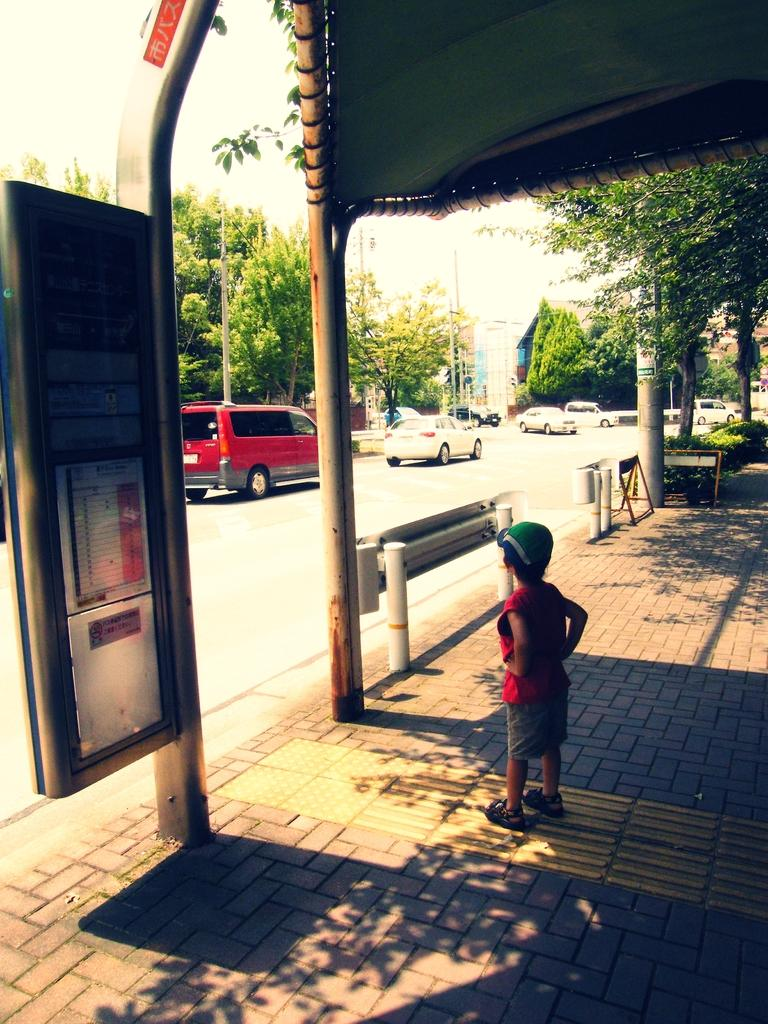What is the kid doing in the image? The kid is standing on the floor in the image. What can be seen on the road in the image? Motor vehicles are present on the road. What type of natural elements are visible in the image? Trees and bushes are visible in the image. What man-made structures can be seen in the image? Electric poles, electric cables, and information boards are present in the image. What part of the natural environment is visible in the image? The sky is visible in the image. What type of fork is being used by the kid in the image? There is no fork present in the image; the kid is standing on the floor. 